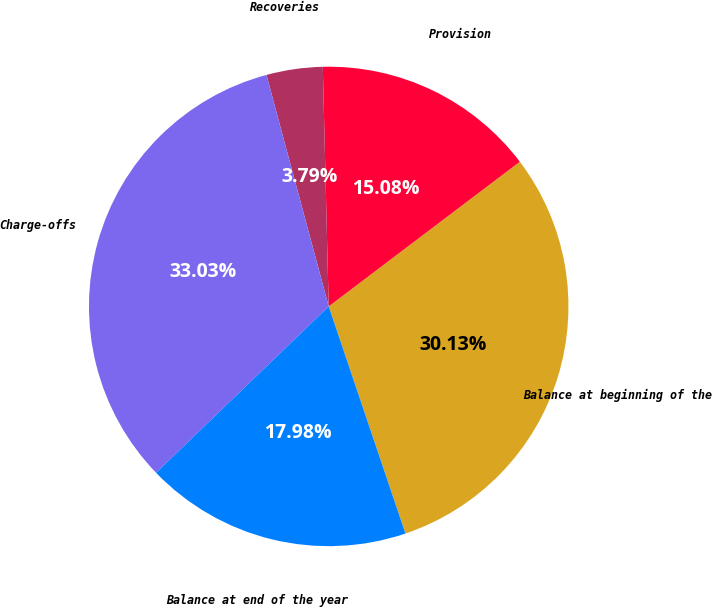Convert chart to OTSL. <chart><loc_0><loc_0><loc_500><loc_500><pie_chart><fcel>Balance at beginning of the<fcel>Provision<fcel>Recoveries<fcel>Charge-offs<fcel>Balance at end of the year<nl><fcel>30.13%<fcel>15.08%<fcel>3.79%<fcel>33.03%<fcel>17.98%<nl></chart> 